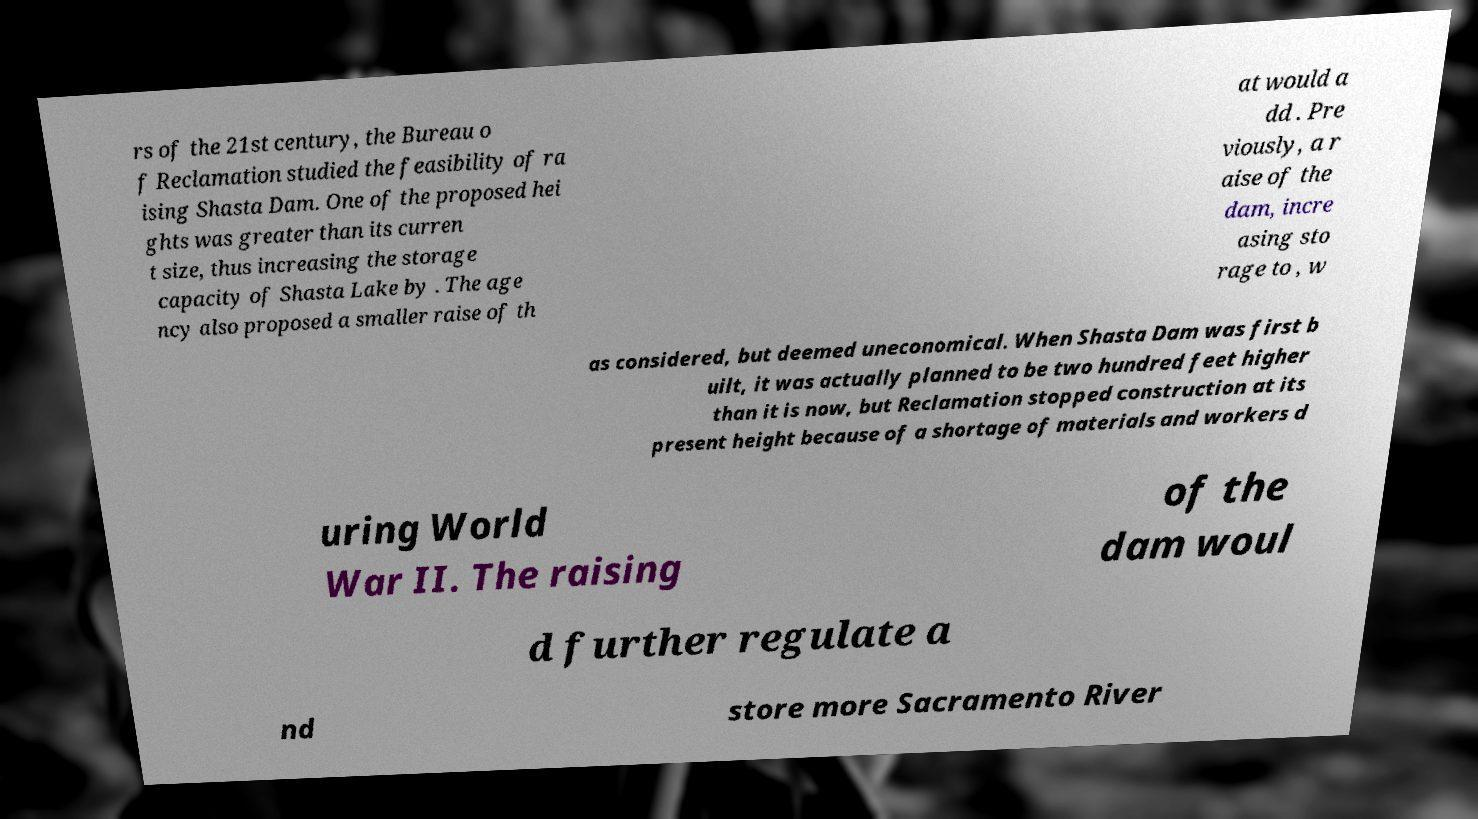I need the written content from this picture converted into text. Can you do that? rs of the 21st century, the Bureau o f Reclamation studied the feasibility of ra ising Shasta Dam. One of the proposed hei ghts was greater than its curren t size, thus increasing the storage capacity of Shasta Lake by . The age ncy also proposed a smaller raise of th at would a dd . Pre viously, a r aise of the dam, incre asing sto rage to , w as considered, but deemed uneconomical. When Shasta Dam was first b uilt, it was actually planned to be two hundred feet higher than it is now, but Reclamation stopped construction at its present height because of a shortage of materials and workers d uring World War II. The raising of the dam woul d further regulate a nd store more Sacramento River 